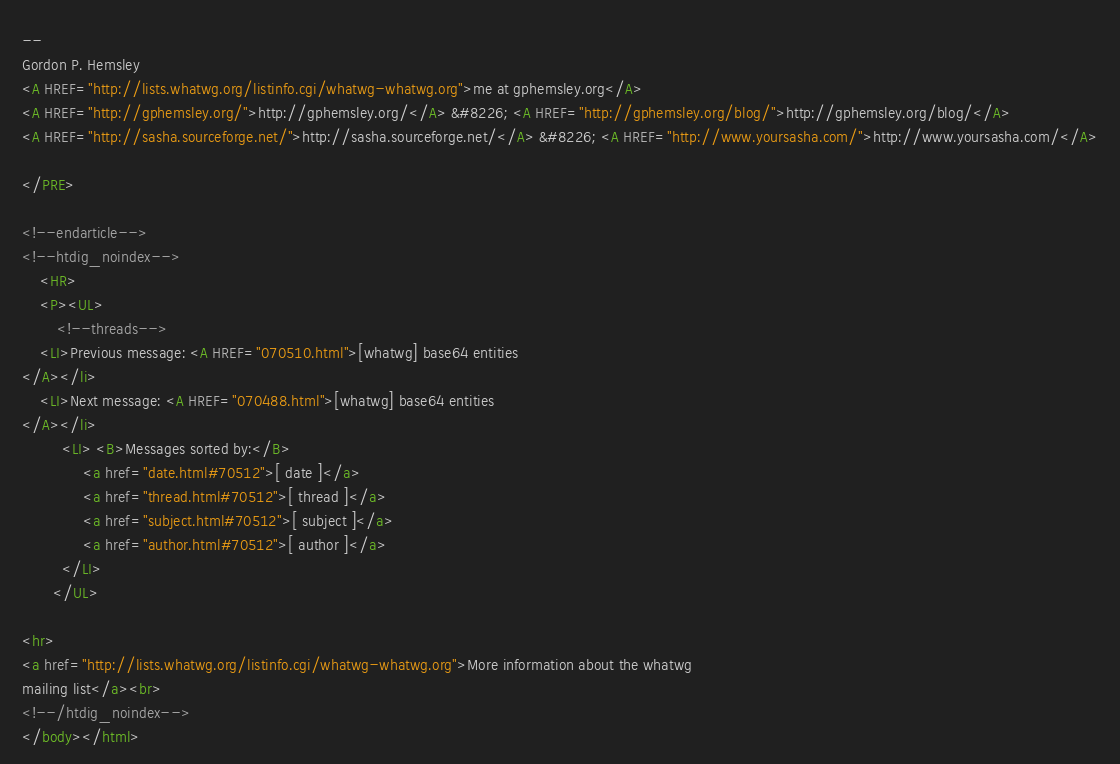<code> <loc_0><loc_0><loc_500><loc_500><_HTML_>
--
Gordon P. Hemsley
<A HREF="http://lists.whatwg.org/listinfo.cgi/whatwg-whatwg.org">me at gphemsley.org</A>
<A HREF="http://gphemsley.org/">http://gphemsley.org/</A> &#8226; <A HREF="http://gphemsley.org/blog/">http://gphemsley.org/blog/</A>
<A HREF="http://sasha.sourceforge.net/">http://sasha.sourceforge.net/</A> &#8226; <A HREF="http://www.yoursasha.com/">http://www.yoursasha.com/</A>

</PRE>

<!--endarticle-->
<!--htdig_noindex-->
    <HR>
    <P><UL>
        <!--threads-->
	<LI>Previous message: <A HREF="070510.html">[whatwg] base64 entities
</A></li>
	<LI>Next message: <A HREF="070488.html">[whatwg] base64 entities
</A></li>
         <LI> <B>Messages sorted by:</B> 
              <a href="date.html#70512">[ date ]</a>
              <a href="thread.html#70512">[ thread ]</a>
              <a href="subject.html#70512">[ subject ]</a>
              <a href="author.html#70512">[ author ]</a>
         </LI>
       </UL>

<hr>
<a href="http://lists.whatwg.org/listinfo.cgi/whatwg-whatwg.org">More information about the whatwg
mailing list</a><br>
<!--/htdig_noindex-->
</body></html>
</code> 